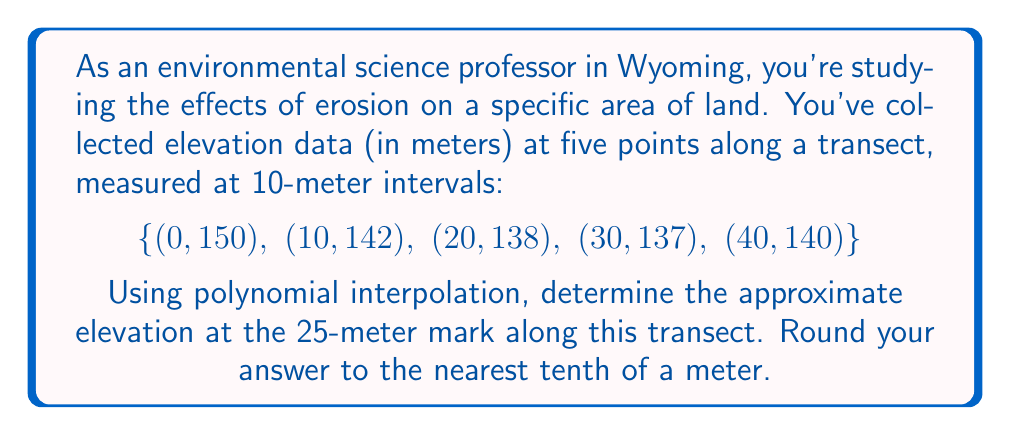Can you answer this question? To solve this problem, we'll use Lagrange polynomial interpolation. The Lagrange interpolation formula is:

$$P(x) = \sum_{i=1}^n y_i \prod_{j \neq i} \frac{x - x_j}{x_i - x_j}$$

Where $(x_i, y_i)$ are the given data points.

For our data:
$(x_1, y_1) = (0, 150)$
$(x_2, y_2) = (10, 142)$
$(x_3, y_3) = (20, 138)$
$(x_4, y_4) = (30, 137)$
$(x_5, y_5) = (40, 140)$

We want to find $P(25)$. Let's calculate each term:

1) $L_1(25) = \frac{(25-10)(25-20)(25-30)(25-40)}{(0-10)(0-20)(0-30)(0-40)} = \frac{15 \cdot 5 \cdot (-5) \cdot (-15)}{-10 \cdot -20 \cdot -30 \cdot -40} = -0.0703125$

2) $L_2(25) = \frac{(25-0)(25-20)(25-30)(25-40)}{(10-0)(10-20)(10-30)(10-40)} = \frac{25 \cdot 5 \cdot (-5) \cdot (-15)}{10 \cdot -10 \cdot -20 \cdot -30} = 0.3125$

3) $L_3(25) = \frac{(25-0)(25-10)(25-30)(25-40)}{(20-0)(20-10)(20-30)(20-40)} = \frac{25 \cdot 15 \cdot (-5) \cdot (-15)}{20 \cdot 10 \cdot -10 \cdot -20} = 0.703125$

4) $L_4(25) = \frac{(25-0)(25-10)(25-20)(25-40)}{(30-0)(30-10)(30-20)(30-40)} = \frac{25 \cdot 15 \cdot 5 \cdot (-15)}{30 \cdot 20 \cdot 10 \cdot -10} = -0.3125$

5) $L_5(25) = \frac{(25-0)(25-10)(25-20)(25-30)}{(40-0)(40-10)(40-20)(40-30)} = \frac{25 \cdot 15 \cdot 5 \cdot (-5)}{40 \cdot 30 \cdot 20 \cdot 10} = 0.0703125$

Now, we can calculate $P(25)$:

$P(25) = 150 \cdot (-0.0703125) + 142 \cdot 0.3125 + 138 \cdot 0.703125 + 137 \cdot (-0.3125) + 140 \cdot 0.0703125$

$P(25) = -10.546875 + 44.375 + 97.03125 - 42.8125 + 9.84375$

$P(25) = 137.890625$

Rounding to the nearest tenth:
$P(25) \approx 137.9$ meters
Answer: 137.9 meters 